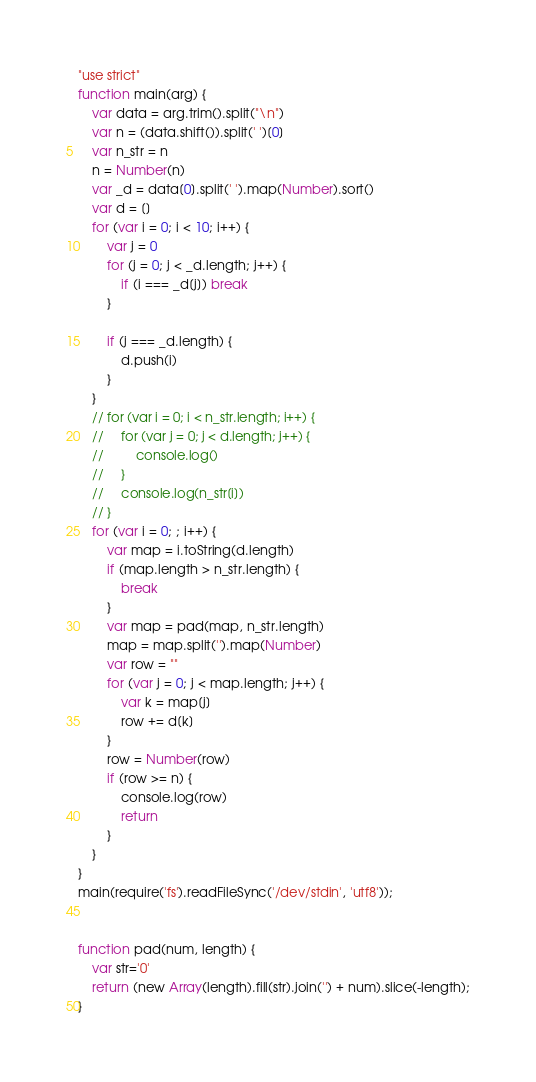Convert code to text. <code><loc_0><loc_0><loc_500><loc_500><_JavaScript_>"use strict"
function main(arg) {
    var data = arg.trim().split("\n")
    var n = (data.shift()).split(' ')[0]
    var n_str = n
    n = Number(n)
    var _d = data[0].split(' ').map(Number).sort()
    var d = []
    for (var i = 0; i < 10; i++) {
        var j = 0
        for (j = 0; j < _d.length; j++) {
            if (i === _d[j]) break
        }
        
        if (j === _d.length) {
            d.push(i)
        }
    }
    // for (var i = 0; i < n_str.length; i++) {
    //     for (var j = 0; j < d.length; j++) {
    //         console.log()
    //     }
    //     console.log(n_str[i])
    // }
    for (var i = 0; ; i++) {
        var map = i.toString(d.length)
        if (map.length > n_str.length) {
            break
        }
        var map = pad(map, n_str.length)
        map = map.split('').map(Number)
        var row = ""
        for (var j = 0; j < map.length; j++) {
            var k = map[j]
            row += d[k]
        }
        row = Number(row)
        if (row >= n) {
            console.log(row)
            return
        }
    }
}
main(require('fs').readFileSync('/dev/stdin', 'utf8'));


function pad(num, length) {
    var str='0'
    return (new Array(length).fill(str).join('') + num).slice(-length);
}</code> 